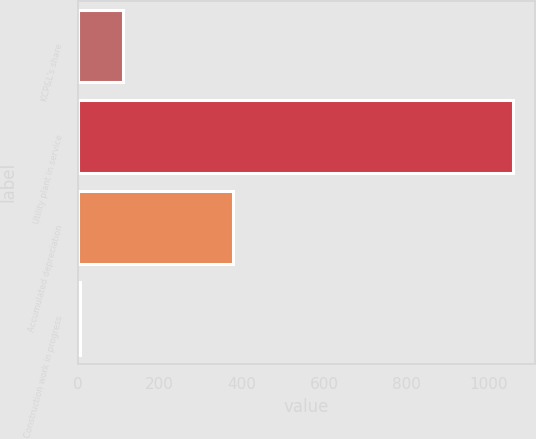<chart> <loc_0><loc_0><loc_500><loc_500><bar_chart><fcel>KCP&L's share<fcel>Utility plant in service<fcel>Accumulated depreciation<fcel>Construction work in progress<nl><fcel>111.61<fcel>1060.3<fcel>378.4<fcel>6.2<nl></chart> 